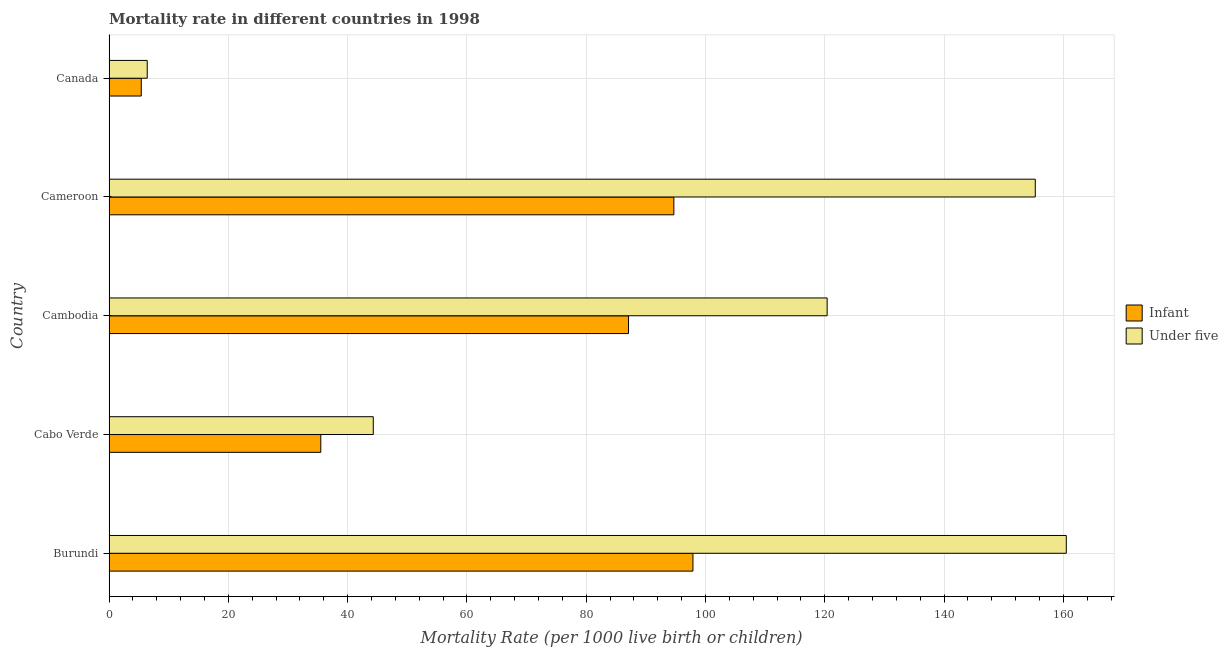How many different coloured bars are there?
Your answer should be compact. 2. Are the number of bars per tick equal to the number of legend labels?
Offer a very short reply. Yes. Are the number of bars on each tick of the Y-axis equal?
Offer a terse response. Yes. How many bars are there on the 4th tick from the top?
Make the answer very short. 2. What is the label of the 5th group of bars from the top?
Provide a succinct answer. Burundi. In how many cases, is the number of bars for a given country not equal to the number of legend labels?
Your answer should be very brief. 0. What is the infant mortality rate in Burundi?
Offer a terse response. 97.9. Across all countries, what is the maximum under-5 mortality rate?
Your response must be concise. 160.5. Across all countries, what is the minimum infant mortality rate?
Keep it short and to the point. 5.4. In which country was the infant mortality rate maximum?
Your answer should be compact. Burundi. What is the total under-5 mortality rate in the graph?
Your answer should be compact. 486.9. What is the difference between the under-5 mortality rate in Cabo Verde and that in Canada?
Your answer should be very brief. 37.9. What is the difference between the infant mortality rate in Cameroon and the under-5 mortality rate in Cambodia?
Your answer should be very brief. -25.7. What is the average under-5 mortality rate per country?
Give a very brief answer. 97.38. What is the difference between the infant mortality rate and under-5 mortality rate in Cabo Verde?
Your answer should be compact. -8.8. In how many countries, is the infant mortality rate greater than 60 ?
Your answer should be compact. 3. What is the ratio of the infant mortality rate in Cameroon to that in Canada?
Your answer should be compact. 17.54. What is the difference between the highest and the lowest infant mortality rate?
Provide a succinct answer. 92.5. Is the sum of the infant mortality rate in Burundi and Canada greater than the maximum under-5 mortality rate across all countries?
Provide a short and direct response. No. What does the 1st bar from the top in Cabo Verde represents?
Your answer should be compact. Under five. What does the 2nd bar from the bottom in Cabo Verde represents?
Give a very brief answer. Under five. Are all the bars in the graph horizontal?
Your answer should be very brief. Yes. What is the difference between two consecutive major ticks on the X-axis?
Offer a very short reply. 20. Does the graph contain grids?
Provide a short and direct response. Yes. How many legend labels are there?
Ensure brevity in your answer.  2. What is the title of the graph?
Provide a short and direct response. Mortality rate in different countries in 1998. Does "Girls" appear as one of the legend labels in the graph?
Give a very brief answer. No. What is the label or title of the X-axis?
Provide a succinct answer. Mortality Rate (per 1000 live birth or children). What is the label or title of the Y-axis?
Provide a short and direct response. Country. What is the Mortality Rate (per 1000 live birth or children) in Infant in Burundi?
Provide a succinct answer. 97.9. What is the Mortality Rate (per 1000 live birth or children) of Under five in Burundi?
Ensure brevity in your answer.  160.5. What is the Mortality Rate (per 1000 live birth or children) of Infant in Cabo Verde?
Your answer should be very brief. 35.5. What is the Mortality Rate (per 1000 live birth or children) in Under five in Cabo Verde?
Give a very brief answer. 44.3. What is the Mortality Rate (per 1000 live birth or children) in Infant in Cambodia?
Ensure brevity in your answer.  87.1. What is the Mortality Rate (per 1000 live birth or children) of Under five in Cambodia?
Your answer should be compact. 120.4. What is the Mortality Rate (per 1000 live birth or children) of Infant in Cameroon?
Provide a succinct answer. 94.7. What is the Mortality Rate (per 1000 live birth or children) in Under five in Cameroon?
Your response must be concise. 155.3. What is the Mortality Rate (per 1000 live birth or children) of Infant in Canada?
Your answer should be compact. 5.4. Across all countries, what is the maximum Mortality Rate (per 1000 live birth or children) in Infant?
Offer a very short reply. 97.9. Across all countries, what is the maximum Mortality Rate (per 1000 live birth or children) of Under five?
Give a very brief answer. 160.5. Across all countries, what is the minimum Mortality Rate (per 1000 live birth or children) of Infant?
Offer a very short reply. 5.4. What is the total Mortality Rate (per 1000 live birth or children) in Infant in the graph?
Provide a succinct answer. 320.6. What is the total Mortality Rate (per 1000 live birth or children) of Under five in the graph?
Your response must be concise. 486.9. What is the difference between the Mortality Rate (per 1000 live birth or children) in Infant in Burundi and that in Cabo Verde?
Give a very brief answer. 62.4. What is the difference between the Mortality Rate (per 1000 live birth or children) of Under five in Burundi and that in Cabo Verde?
Ensure brevity in your answer.  116.2. What is the difference between the Mortality Rate (per 1000 live birth or children) of Under five in Burundi and that in Cambodia?
Your answer should be compact. 40.1. What is the difference between the Mortality Rate (per 1000 live birth or children) in Under five in Burundi and that in Cameroon?
Offer a very short reply. 5.2. What is the difference between the Mortality Rate (per 1000 live birth or children) of Infant in Burundi and that in Canada?
Your response must be concise. 92.5. What is the difference between the Mortality Rate (per 1000 live birth or children) of Under five in Burundi and that in Canada?
Provide a short and direct response. 154.1. What is the difference between the Mortality Rate (per 1000 live birth or children) of Infant in Cabo Verde and that in Cambodia?
Give a very brief answer. -51.6. What is the difference between the Mortality Rate (per 1000 live birth or children) of Under five in Cabo Verde and that in Cambodia?
Offer a very short reply. -76.1. What is the difference between the Mortality Rate (per 1000 live birth or children) in Infant in Cabo Verde and that in Cameroon?
Give a very brief answer. -59.2. What is the difference between the Mortality Rate (per 1000 live birth or children) in Under five in Cabo Verde and that in Cameroon?
Make the answer very short. -111. What is the difference between the Mortality Rate (per 1000 live birth or children) of Infant in Cabo Verde and that in Canada?
Make the answer very short. 30.1. What is the difference between the Mortality Rate (per 1000 live birth or children) of Under five in Cabo Verde and that in Canada?
Give a very brief answer. 37.9. What is the difference between the Mortality Rate (per 1000 live birth or children) of Infant in Cambodia and that in Cameroon?
Ensure brevity in your answer.  -7.6. What is the difference between the Mortality Rate (per 1000 live birth or children) of Under five in Cambodia and that in Cameroon?
Your answer should be compact. -34.9. What is the difference between the Mortality Rate (per 1000 live birth or children) in Infant in Cambodia and that in Canada?
Give a very brief answer. 81.7. What is the difference between the Mortality Rate (per 1000 live birth or children) of Under five in Cambodia and that in Canada?
Offer a terse response. 114. What is the difference between the Mortality Rate (per 1000 live birth or children) of Infant in Cameroon and that in Canada?
Ensure brevity in your answer.  89.3. What is the difference between the Mortality Rate (per 1000 live birth or children) of Under five in Cameroon and that in Canada?
Your answer should be very brief. 148.9. What is the difference between the Mortality Rate (per 1000 live birth or children) in Infant in Burundi and the Mortality Rate (per 1000 live birth or children) in Under five in Cabo Verde?
Provide a succinct answer. 53.6. What is the difference between the Mortality Rate (per 1000 live birth or children) in Infant in Burundi and the Mortality Rate (per 1000 live birth or children) in Under five in Cambodia?
Keep it short and to the point. -22.5. What is the difference between the Mortality Rate (per 1000 live birth or children) in Infant in Burundi and the Mortality Rate (per 1000 live birth or children) in Under five in Cameroon?
Offer a very short reply. -57.4. What is the difference between the Mortality Rate (per 1000 live birth or children) in Infant in Burundi and the Mortality Rate (per 1000 live birth or children) in Under five in Canada?
Give a very brief answer. 91.5. What is the difference between the Mortality Rate (per 1000 live birth or children) of Infant in Cabo Verde and the Mortality Rate (per 1000 live birth or children) of Under five in Cambodia?
Keep it short and to the point. -84.9. What is the difference between the Mortality Rate (per 1000 live birth or children) in Infant in Cabo Verde and the Mortality Rate (per 1000 live birth or children) in Under five in Cameroon?
Make the answer very short. -119.8. What is the difference between the Mortality Rate (per 1000 live birth or children) in Infant in Cabo Verde and the Mortality Rate (per 1000 live birth or children) in Under five in Canada?
Keep it short and to the point. 29.1. What is the difference between the Mortality Rate (per 1000 live birth or children) in Infant in Cambodia and the Mortality Rate (per 1000 live birth or children) in Under five in Cameroon?
Ensure brevity in your answer.  -68.2. What is the difference between the Mortality Rate (per 1000 live birth or children) in Infant in Cambodia and the Mortality Rate (per 1000 live birth or children) in Under five in Canada?
Give a very brief answer. 80.7. What is the difference between the Mortality Rate (per 1000 live birth or children) of Infant in Cameroon and the Mortality Rate (per 1000 live birth or children) of Under five in Canada?
Offer a terse response. 88.3. What is the average Mortality Rate (per 1000 live birth or children) of Infant per country?
Provide a succinct answer. 64.12. What is the average Mortality Rate (per 1000 live birth or children) in Under five per country?
Your answer should be very brief. 97.38. What is the difference between the Mortality Rate (per 1000 live birth or children) in Infant and Mortality Rate (per 1000 live birth or children) in Under five in Burundi?
Make the answer very short. -62.6. What is the difference between the Mortality Rate (per 1000 live birth or children) in Infant and Mortality Rate (per 1000 live birth or children) in Under five in Cambodia?
Keep it short and to the point. -33.3. What is the difference between the Mortality Rate (per 1000 live birth or children) in Infant and Mortality Rate (per 1000 live birth or children) in Under five in Cameroon?
Your answer should be very brief. -60.6. What is the difference between the Mortality Rate (per 1000 live birth or children) in Infant and Mortality Rate (per 1000 live birth or children) in Under five in Canada?
Provide a succinct answer. -1. What is the ratio of the Mortality Rate (per 1000 live birth or children) in Infant in Burundi to that in Cabo Verde?
Offer a terse response. 2.76. What is the ratio of the Mortality Rate (per 1000 live birth or children) in Under five in Burundi to that in Cabo Verde?
Offer a terse response. 3.62. What is the ratio of the Mortality Rate (per 1000 live birth or children) of Infant in Burundi to that in Cambodia?
Your answer should be very brief. 1.12. What is the ratio of the Mortality Rate (per 1000 live birth or children) in Under five in Burundi to that in Cambodia?
Keep it short and to the point. 1.33. What is the ratio of the Mortality Rate (per 1000 live birth or children) in Infant in Burundi to that in Cameroon?
Your answer should be very brief. 1.03. What is the ratio of the Mortality Rate (per 1000 live birth or children) in Under five in Burundi to that in Cameroon?
Your answer should be very brief. 1.03. What is the ratio of the Mortality Rate (per 1000 live birth or children) in Infant in Burundi to that in Canada?
Make the answer very short. 18.13. What is the ratio of the Mortality Rate (per 1000 live birth or children) of Under five in Burundi to that in Canada?
Give a very brief answer. 25.08. What is the ratio of the Mortality Rate (per 1000 live birth or children) of Infant in Cabo Verde to that in Cambodia?
Your answer should be compact. 0.41. What is the ratio of the Mortality Rate (per 1000 live birth or children) of Under five in Cabo Verde to that in Cambodia?
Offer a terse response. 0.37. What is the ratio of the Mortality Rate (per 1000 live birth or children) in Infant in Cabo Verde to that in Cameroon?
Ensure brevity in your answer.  0.37. What is the ratio of the Mortality Rate (per 1000 live birth or children) of Under five in Cabo Verde to that in Cameroon?
Your response must be concise. 0.29. What is the ratio of the Mortality Rate (per 1000 live birth or children) of Infant in Cabo Verde to that in Canada?
Your response must be concise. 6.57. What is the ratio of the Mortality Rate (per 1000 live birth or children) in Under five in Cabo Verde to that in Canada?
Make the answer very short. 6.92. What is the ratio of the Mortality Rate (per 1000 live birth or children) of Infant in Cambodia to that in Cameroon?
Offer a very short reply. 0.92. What is the ratio of the Mortality Rate (per 1000 live birth or children) of Under five in Cambodia to that in Cameroon?
Keep it short and to the point. 0.78. What is the ratio of the Mortality Rate (per 1000 live birth or children) in Infant in Cambodia to that in Canada?
Make the answer very short. 16.13. What is the ratio of the Mortality Rate (per 1000 live birth or children) in Under five in Cambodia to that in Canada?
Your answer should be compact. 18.81. What is the ratio of the Mortality Rate (per 1000 live birth or children) in Infant in Cameroon to that in Canada?
Provide a short and direct response. 17.54. What is the ratio of the Mortality Rate (per 1000 live birth or children) in Under five in Cameroon to that in Canada?
Make the answer very short. 24.27. What is the difference between the highest and the second highest Mortality Rate (per 1000 live birth or children) in Infant?
Your answer should be compact. 3.2. What is the difference between the highest and the second highest Mortality Rate (per 1000 live birth or children) in Under five?
Ensure brevity in your answer.  5.2. What is the difference between the highest and the lowest Mortality Rate (per 1000 live birth or children) of Infant?
Make the answer very short. 92.5. What is the difference between the highest and the lowest Mortality Rate (per 1000 live birth or children) of Under five?
Offer a terse response. 154.1. 